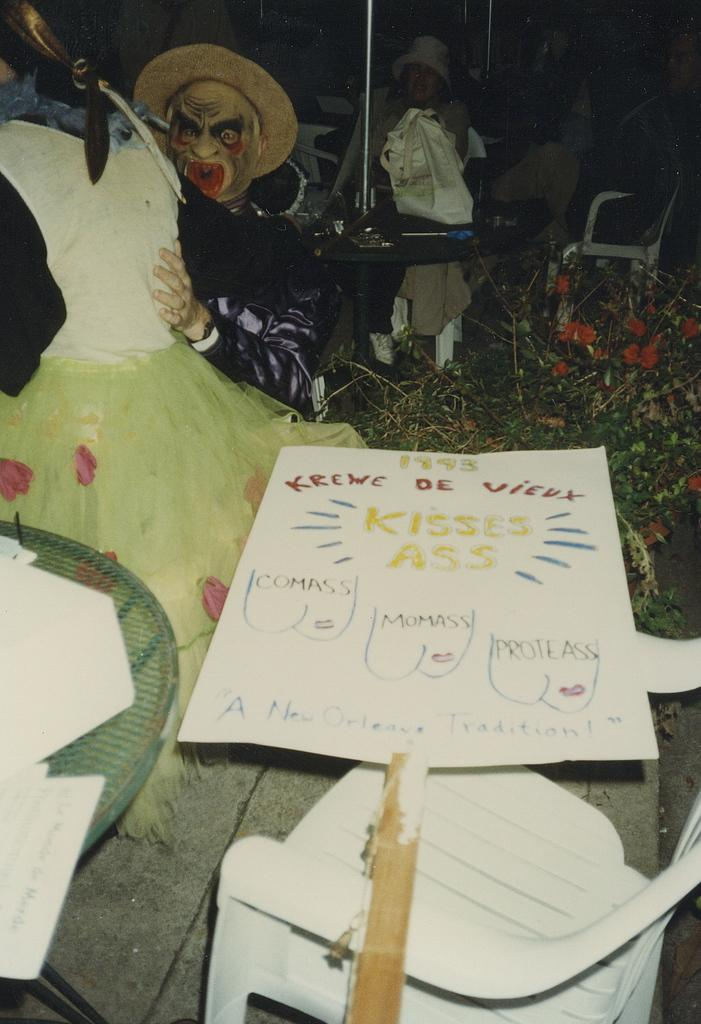<image>
Present a compact description of the photo's key features. a paper with kisses ass written on it 